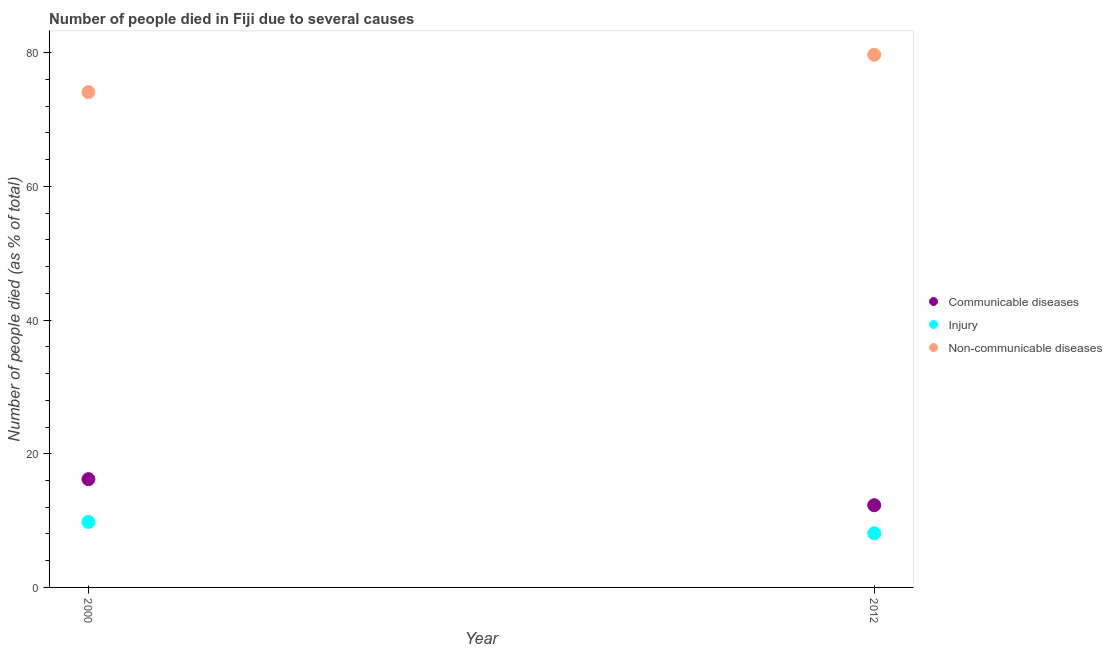What is the number of people who died of injury in 2012?
Give a very brief answer. 8.1. Across all years, what is the maximum number of people who died of communicable diseases?
Keep it short and to the point. 16.2. Across all years, what is the minimum number of people who dies of non-communicable diseases?
Offer a terse response. 74.1. What is the total number of people who died of communicable diseases in the graph?
Offer a very short reply. 28.5. What is the difference between the number of people who died of injury in 2000 and that in 2012?
Provide a short and direct response. 1.7. What is the difference between the number of people who dies of non-communicable diseases in 2012 and the number of people who died of injury in 2000?
Give a very brief answer. 69.9. What is the average number of people who died of communicable diseases per year?
Your answer should be very brief. 14.25. In the year 2000, what is the difference between the number of people who dies of non-communicable diseases and number of people who died of injury?
Make the answer very short. 64.3. What is the ratio of the number of people who dies of non-communicable diseases in 2000 to that in 2012?
Your answer should be compact. 0.93. Is the number of people who died of communicable diseases in 2000 less than that in 2012?
Make the answer very short. No. In how many years, is the number of people who dies of non-communicable diseases greater than the average number of people who dies of non-communicable diseases taken over all years?
Give a very brief answer. 1. Is it the case that in every year, the sum of the number of people who died of communicable diseases and number of people who died of injury is greater than the number of people who dies of non-communicable diseases?
Offer a terse response. No. Is the number of people who died of communicable diseases strictly greater than the number of people who died of injury over the years?
Your response must be concise. Yes. How many dotlines are there?
Your answer should be compact. 3. How many years are there in the graph?
Ensure brevity in your answer.  2. What is the difference between two consecutive major ticks on the Y-axis?
Offer a terse response. 20. Does the graph contain any zero values?
Your answer should be very brief. No. Does the graph contain grids?
Your answer should be very brief. No. How many legend labels are there?
Ensure brevity in your answer.  3. What is the title of the graph?
Offer a terse response. Number of people died in Fiji due to several causes. What is the label or title of the Y-axis?
Provide a succinct answer. Number of people died (as % of total). What is the Number of people died (as % of total) in Injury in 2000?
Keep it short and to the point. 9.8. What is the Number of people died (as % of total) of Non-communicable diseases in 2000?
Your answer should be very brief. 74.1. What is the Number of people died (as % of total) in Injury in 2012?
Keep it short and to the point. 8.1. What is the Number of people died (as % of total) in Non-communicable diseases in 2012?
Your response must be concise. 79.7. Across all years, what is the maximum Number of people died (as % of total) of Injury?
Offer a terse response. 9.8. Across all years, what is the maximum Number of people died (as % of total) in Non-communicable diseases?
Offer a very short reply. 79.7. Across all years, what is the minimum Number of people died (as % of total) in Non-communicable diseases?
Give a very brief answer. 74.1. What is the total Number of people died (as % of total) in Non-communicable diseases in the graph?
Offer a terse response. 153.8. What is the difference between the Number of people died (as % of total) in Injury in 2000 and that in 2012?
Make the answer very short. 1.7. What is the difference between the Number of people died (as % of total) of Non-communicable diseases in 2000 and that in 2012?
Make the answer very short. -5.6. What is the difference between the Number of people died (as % of total) of Communicable diseases in 2000 and the Number of people died (as % of total) of Injury in 2012?
Ensure brevity in your answer.  8.1. What is the difference between the Number of people died (as % of total) of Communicable diseases in 2000 and the Number of people died (as % of total) of Non-communicable diseases in 2012?
Make the answer very short. -63.5. What is the difference between the Number of people died (as % of total) of Injury in 2000 and the Number of people died (as % of total) of Non-communicable diseases in 2012?
Keep it short and to the point. -69.9. What is the average Number of people died (as % of total) in Communicable diseases per year?
Your response must be concise. 14.25. What is the average Number of people died (as % of total) in Injury per year?
Provide a succinct answer. 8.95. What is the average Number of people died (as % of total) of Non-communicable diseases per year?
Offer a very short reply. 76.9. In the year 2000, what is the difference between the Number of people died (as % of total) of Communicable diseases and Number of people died (as % of total) of Injury?
Ensure brevity in your answer.  6.4. In the year 2000, what is the difference between the Number of people died (as % of total) of Communicable diseases and Number of people died (as % of total) of Non-communicable diseases?
Your answer should be compact. -57.9. In the year 2000, what is the difference between the Number of people died (as % of total) in Injury and Number of people died (as % of total) in Non-communicable diseases?
Offer a terse response. -64.3. In the year 2012, what is the difference between the Number of people died (as % of total) of Communicable diseases and Number of people died (as % of total) of Injury?
Provide a short and direct response. 4.2. In the year 2012, what is the difference between the Number of people died (as % of total) of Communicable diseases and Number of people died (as % of total) of Non-communicable diseases?
Make the answer very short. -67.4. In the year 2012, what is the difference between the Number of people died (as % of total) in Injury and Number of people died (as % of total) in Non-communicable diseases?
Offer a very short reply. -71.6. What is the ratio of the Number of people died (as % of total) in Communicable diseases in 2000 to that in 2012?
Your answer should be compact. 1.32. What is the ratio of the Number of people died (as % of total) in Injury in 2000 to that in 2012?
Provide a short and direct response. 1.21. What is the ratio of the Number of people died (as % of total) of Non-communicable diseases in 2000 to that in 2012?
Keep it short and to the point. 0.93. What is the difference between the highest and the second highest Number of people died (as % of total) in Injury?
Make the answer very short. 1.7. 